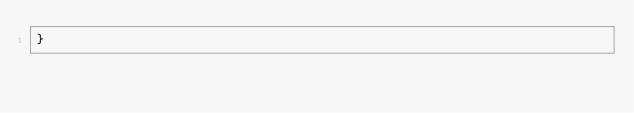Convert code to text. <code><loc_0><loc_0><loc_500><loc_500><_JavaScript_>}</code> 